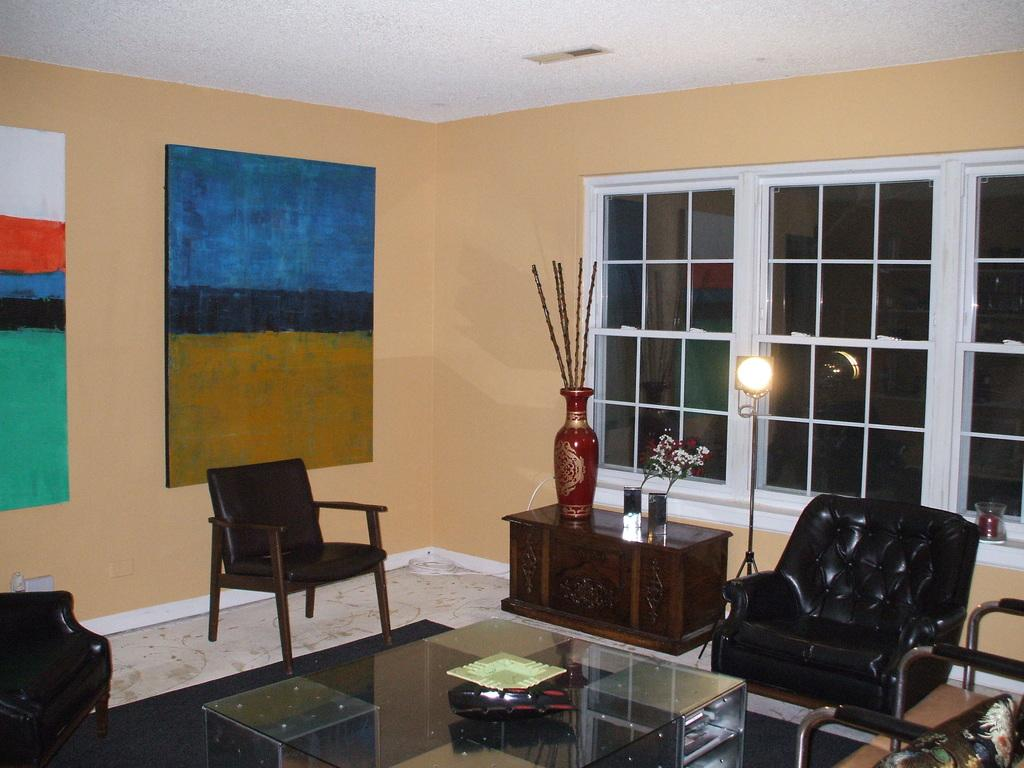What type of space is depicted in the image? The image shows an inner view of a room. What decorative elements can be seen on the walls? There are paintings on the wall. What type of furniture is present in the room? There are chairs in the room. What kind of table is in the room? There is a glass table in the room. What source of illumination is present in the room? There is a light in the room. Can you see any stars in the image? There are no stars visible in the image, as it depicts an inner view of a room with no windows or outdoor elements. 